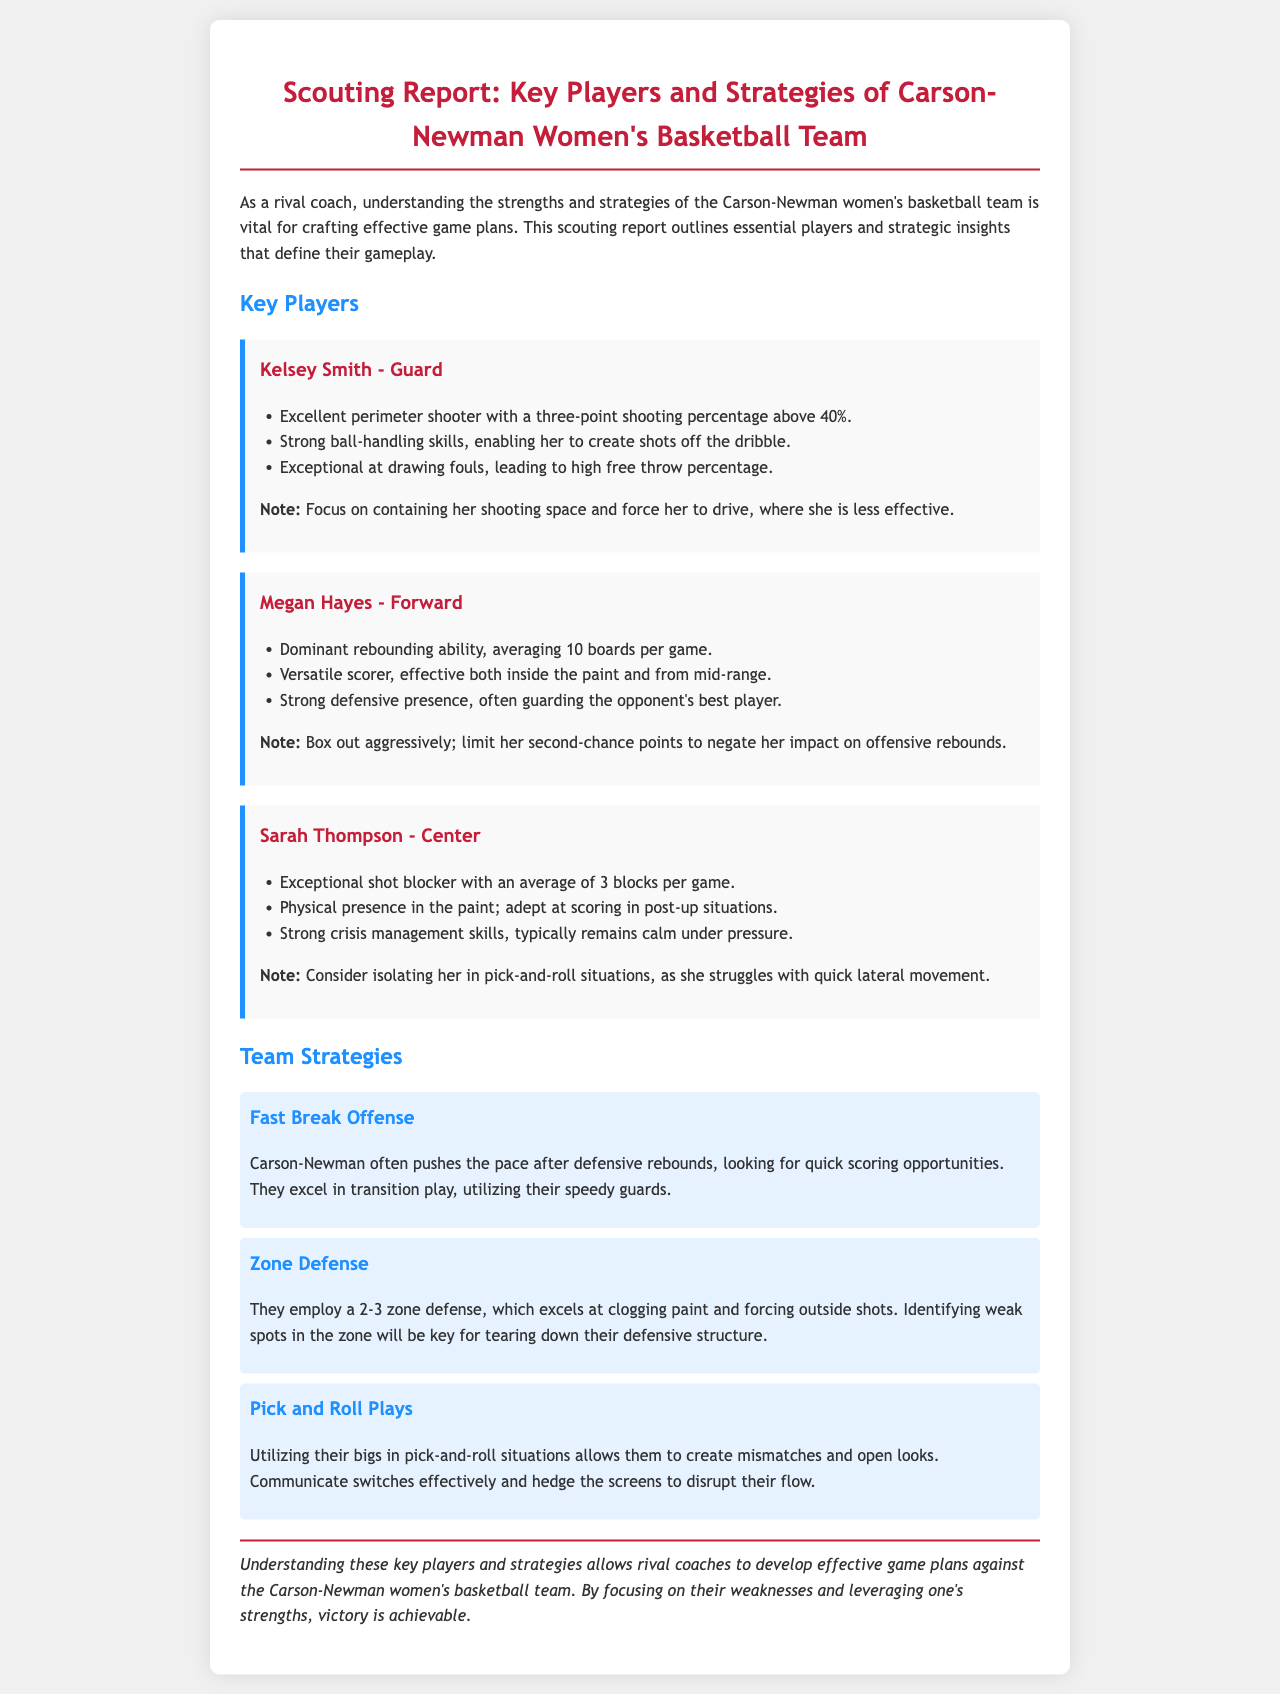What is Kelsey Smith's position? Kelsey Smith is identified as a guard in the document.
Answer: Guard What is Megan Hayes' average rebounds per game? The document states that Megan Hayes averages 10 boards per game.
Answer: 10 How many blocks does Sarah Thompson average per game? Sarah Thompson's average blocks per game is mentioned as 3.
Answer: 3 What kind of defense does Carson-Newman employ? The document specifies that they employ a 2-3 zone defense.
Answer: 2-3 zone What strategy does Carson-Newman use after defensive rebounds? They often push the pace after defensive rebounds for quick scoring opportunities.
Answer: Fast Break Offense What should teams focus on to limit Megan Hayes' impact? The document advises to "Box out aggressively; limit her second-chance points."
Answer: Box out aggressively In which situations does Sarah Thompson struggle? The document states she struggles with quick lateral movement in pick-and-roll situations.
Answer: Quick lateral movement What should be done to disrupt Carson-Newman's pick-and-roll plays? The document suggests communicating switches and hedging the screens to disrupt their flow.
Answer: Communicate switches What is the preferred shooting percentage for Kelsey Smith's three-point shots? Kelsey Smith's three-point shooting percentage is stated to be above 40%.
Answer: Above 40% 